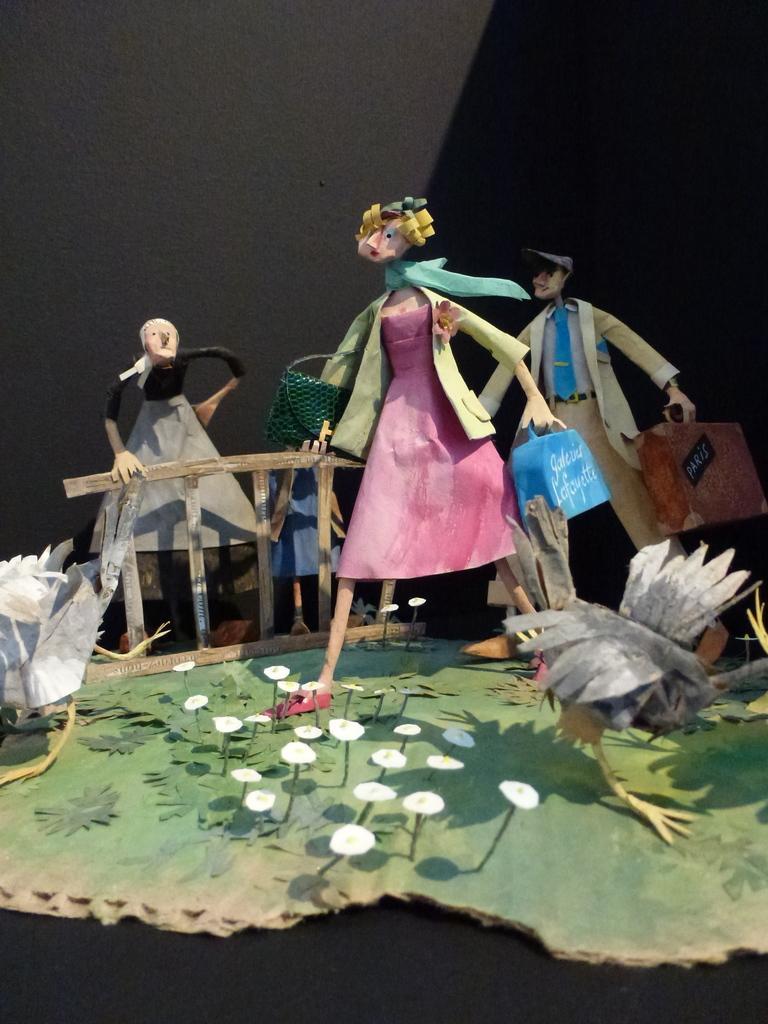Can you describe this image briefly? This image looks like a craft made of cardboard in the foreground. And there is a wall in the background. 